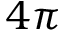Convert formula to latex. <formula><loc_0><loc_0><loc_500><loc_500>4 \pi</formula> 